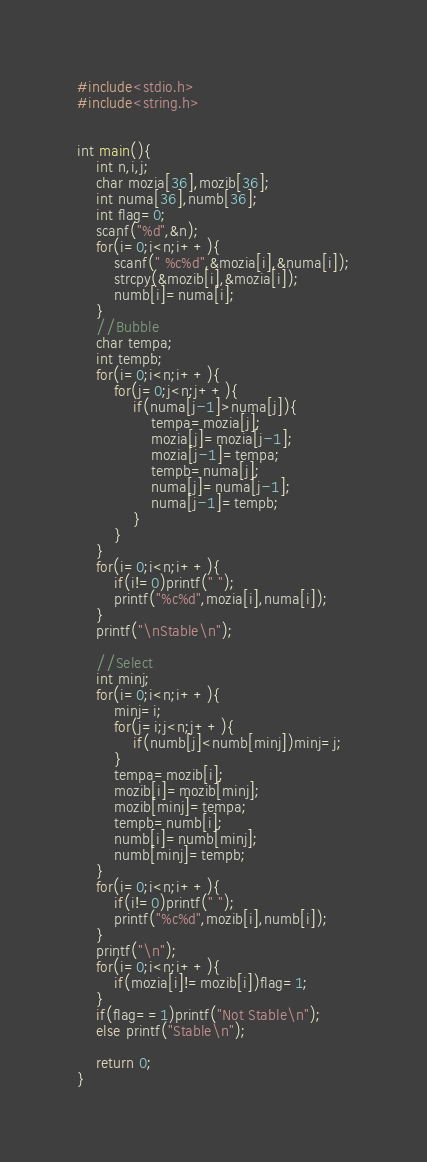Convert code to text. <code><loc_0><loc_0><loc_500><loc_500><_C_>#include<stdio.h>
#include<string.h>


int main(){
    int n,i,j;
    char mozia[36],mozib[36];
    int numa[36],numb[36];
    int flag=0;
    scanf("%d",&n);
    for(i=0;i<n;i++){
        scanf(" %c%d",&mozia[i],&numa[i]);
        strcpy(&mozib[i],&mozia[i]);
        numb[i]=numa[i];
    }
    //Bubble
    char tempa;
    int tempb;
    for(i=0;i<n;i++){
        for(j=0;j<n;j++){
            if(numa[j-1]>numa[j]){
                tempa=mozia[j];
                mozia[j]=mozia[j-1];
                mozia[j-1]=tempa;
                tempb=numa[j];
                numa[j]=numa[j-1];
                numa[j-1]=tempb;
            }
        }
    }
    for(i=0;i<n;i++){
        if(i!=0)printf(" ");
        printf("%c%d",mozia[i],numa[i]);
    }
    printf("\nStable\n");
    
    //Select
    int minj;
    for(i=0;i<n;i++){
        minj=i;
        for(j=i;j<n;j++){
            if(numb[j]<numb[minj])minj=j;
        }
        tempa=mozib[i];
        mozib[i]=mozib[minj];
        mozib[minj]=tempa;
        tempb=numb[i];
        numb[i]=numb[minj];
        numb[minj]=tempb;
    }
    for(i=0;i<n;i++){
        if(i!=0)printf(" ");
        printf("%c%d",mozib[i],numb[i]);
    }
    printf("\n");
    for(i=0;i<n;i++){
        if(mozia[i]!=mozib[i])flag=1;
    }
    if(flag==1)printf("Not Stable\n");
    else printf("Stable\n");
    
    return 0;
}


</code> 